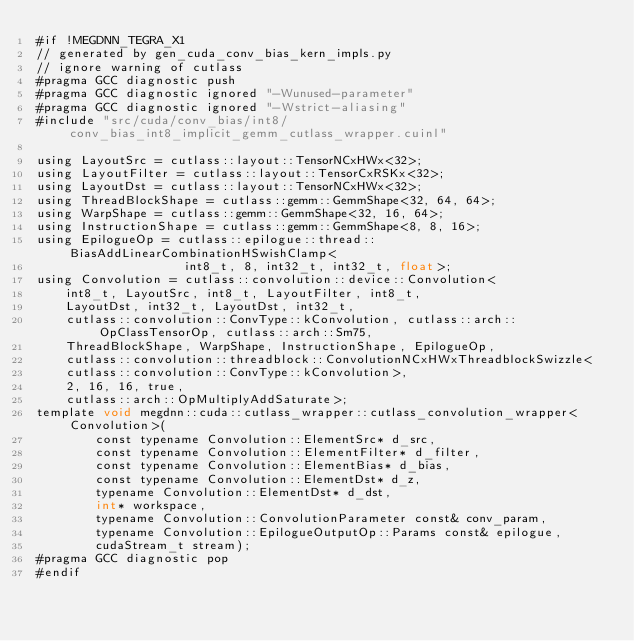Convert code to text. <code><loc_0><loc_0><loc_500><loc_500><_Cuda_>#if !MEGDNN_TEGRA_X1
// generated by gen_cuda_conv_bias_kern_impls.py
// ignore warning of cutlass
#pragma GCC diagnostic push
#pragma GCC diagnostic ignored "-Wunused-parameter"
#pragma GCC diagnostic ignored "-Wstrict-aliasing"
#include "src/cuda/conv_bias/int8/conv_bias_int8_implicit_gemm_cutlass_wrapper.cuinl"

using LayoutSrc = cutlass::layout::TensorNCxHWx<32>;
using LayoutFilter = cutlass::layout::TensorCxRSKx<32>;
using LayoutDst = cutlass::layout::TensorNCxHWx<32>;
using ThreadBlockShape = cutlass::gemm::GemmShape<32, 64, 64>;
using WarpShape = cutlass::gemm::GemmShape<32, 16, 64>;
using InstructionShape = cutlass::gemm::GemmShape<8, 8, 16>;
using EpilogueOp = cutlass::epilogue::thread::BiasAddLinearCombinationHSwishClamp<
                    int8_t, 8, int32_t, int32_t, float>;
using Convolution = cutlass::convolution::device::Convolution<
    int8_t, LayoutSrc, int8_t, LayoutFilter, int8_t, 
    LayoutDst, int32_t, LayoutDst, int32_t, 
    cutlass::convolution::ConvType::kConvolution, cutlass::arch::OpClassTensorOp, cutlass::arch::Sm75, 
    ThreadBlockShape, WarpShape, InstructionShape, EpilogueOp, 
    cutlass::convolution::threadblock::ConvolutionNCxHWxThreadblockSwizzle<
    cutlass::convolution::ConvType::kConvolution>, 
    2, 16, 16, true, 
    cutlass::arch::OpMultiplyAddSaturate>;
template void megdnn::cuda::cutlass_wrapper::cutlass_convolution_wrapper<Convolution>(
        const typename Convolution::ElementSrc* d_src, 
        const typename Convolution::ElementFilter* d_filter, 
        const typename Convolution::ElementBias* d_bias, 
        const typename Convolution::ElementDst* d_z, 
        typename Convolution::ElementDst* d_dst, 
        int* workspace, 
        typename Convolution::ConvolutionParameter const& conv_param, 
        typename Convolution::EpilogueOutputOp::Params const& epilogue, 
        cudaStream_t stream);
#pragma GCC diagnostic pop
#endif
</code> 